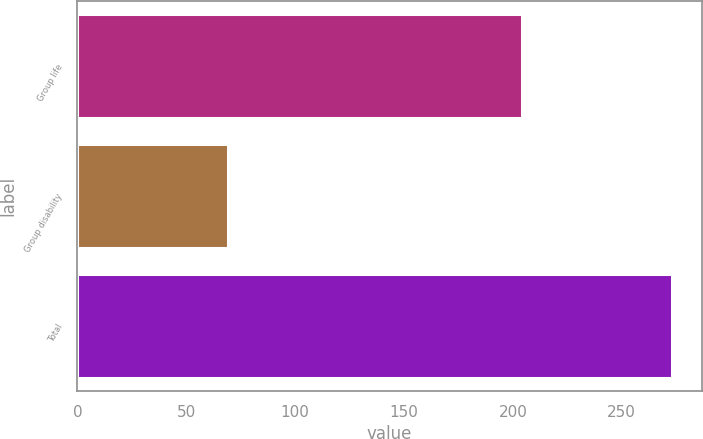Convert chart. <chart><loc_0><loc_0><loc_500><loc_500><bar_chart><fcel>Group life<fcel>Group disability<fcel>Total<nl><fcel>204<fcel>69<fcel>273<nl></chart> 